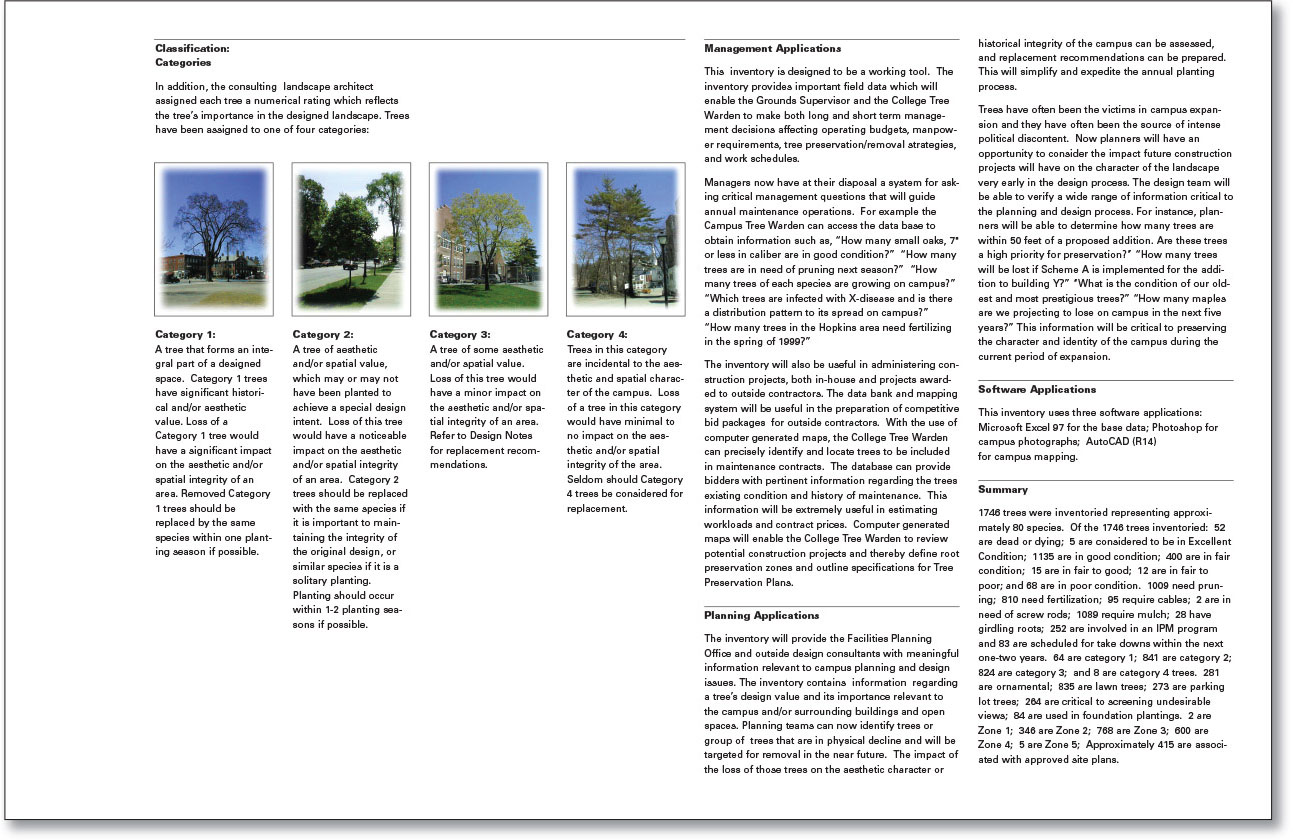Describe the overall distribution and condition of the trees across the campus. The campus has a total of 1746 trees, with condition assessments revealing that 52 are dead or dying, 5 are in excellent condition, 1135 are in good condition, 400 are in fair condition, 158 are in poor condition, and 12 are in very poor condition. The distribution across different categories highlights that Category 1 has 28 trees, Category 2 has 41 trees, Category 3 has 83 trees, and Category 4 has 281 trees. This varied distribution ensures that different areas of the campus have trees with varying levels of impact on aesthetic and spatial integrity. What are the planning applications for this tree inventory on the campus? The tree inventory serves several planning applications, including providing the Facilities Planning Office and outside design consultants with significant information relevant to campus planning and design issues. It details a tree's design value and its importance relative to the campus and surrounding buildings and open spaces. The inventory helps in identifying trees in physical decline or those that should be targeted for removal in the future. It also assists in managing the impacts that the loss of these trees may have on the aesthetic character or historical integrity of the campus. Imagine a futuristic scenario where the campus trees have advanced AI to communicate. How might that affect campus management? In a futuristic scenario where campus trees have advanced AI and the ability to communicate, campus management could experience a significant shift in operations. Trees could provide real-time data on their health, alerting staff to disease outbreaks or nutrient deficiencies directly. They could also communicate their water needs, optimizing irrigation efforts and conserving resources. This advanced interaction might even allow the trees to suggest ideal planting times for new seedlings or recommend the best species to plant in specific areas, enhancing both aesthetics and sustainability. Furthermore, trees with AI could participate in environmental monitoring, contributing data to help manage climate control and air quality on campus. 